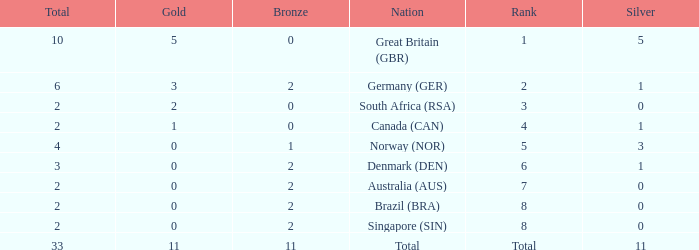What is bronze when the rank is 3 and the total is more than 2? None. 